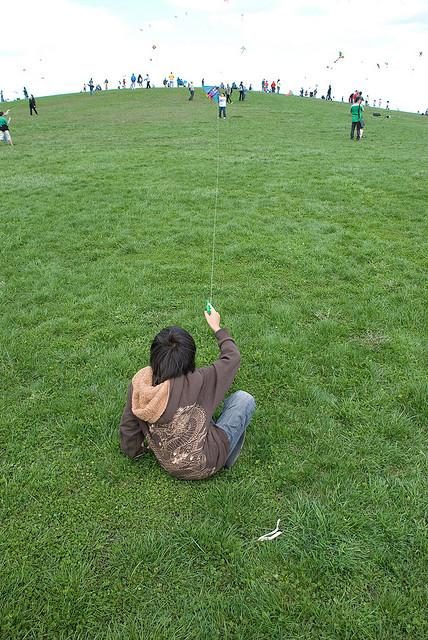What is the boy sitting in the grass doing? flying kite 